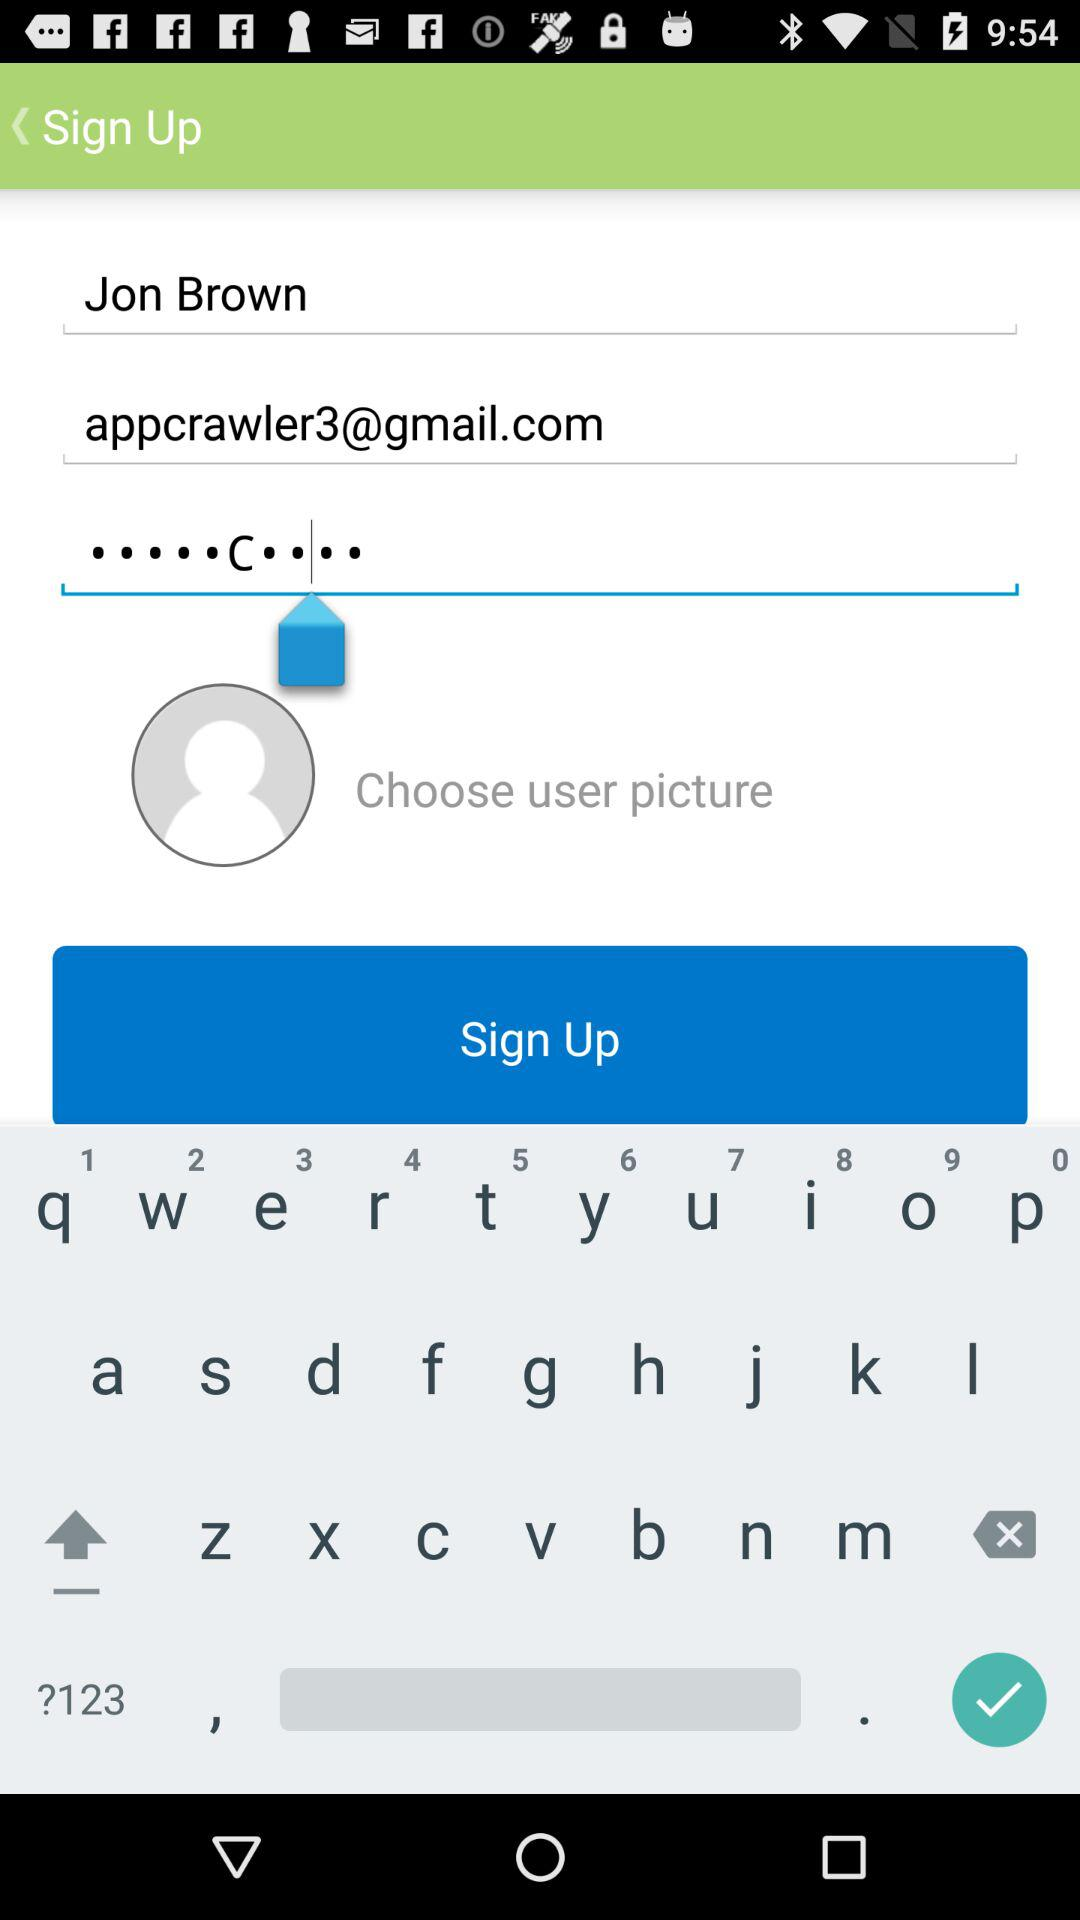How many fields are there to fill out before signing up?
Answer the question using a single word or phrase. 3 